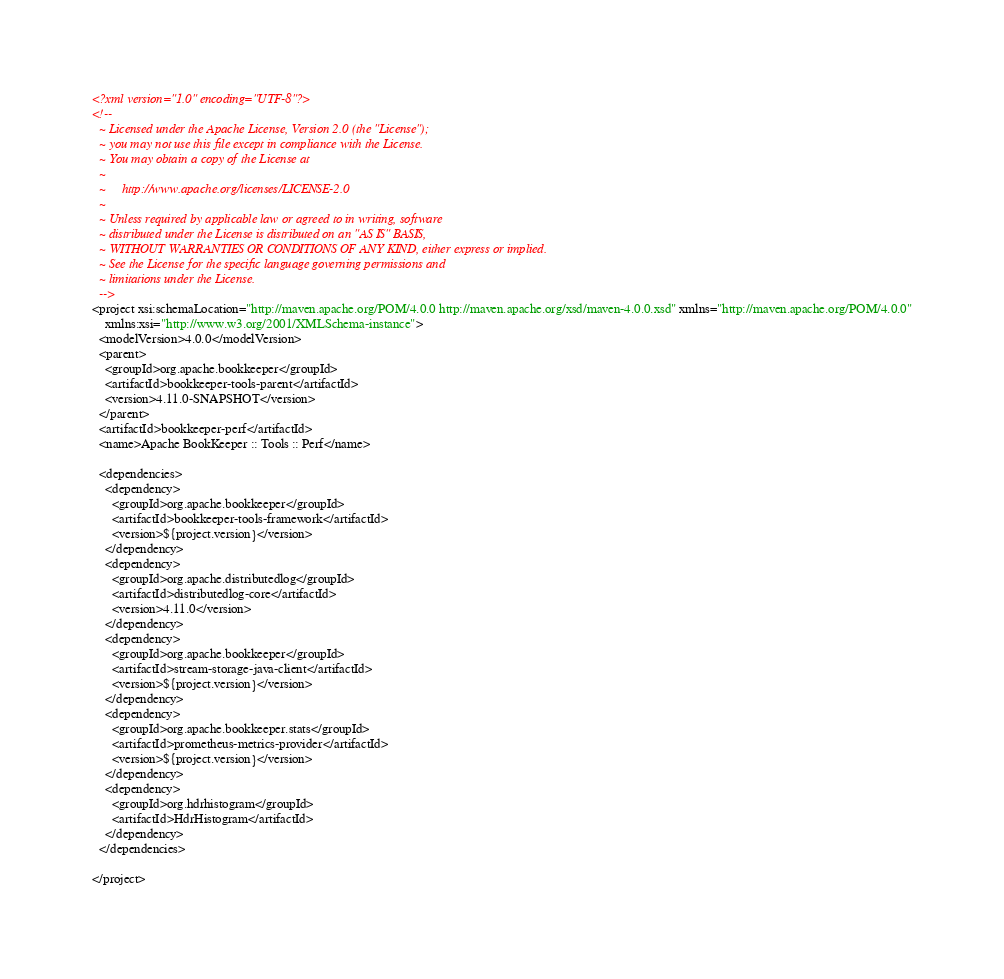Convert code to text. <code><loc_0><loc_0><loc_500><loc_500><_XML_><?xml version="1.0" encoding="UTF-8"?>
<!--
  ~ Licensed under the Apache License, Version 2.0 (the "License");
  ~ you may not use this file except in compliance with the License.
  ~ You may obtain a copy of the License at
  ~
  ~     http://www.apache.org/licenses/LICENSE-2.0
  ~
  ~ Unless required by applicable law or agreed to in writing, software
  ~ distributed under the License is distributed on an "AS IS" BASIS,
  ~ WITHOUT WARRANTIES OR CONDITIONS OF ANY KIND, either express or implied.
  ~ See the License for the specific language governing permissions and
  ~ limitations under the License.
  -->
<project xsi:schemaLocation="http://maven.apache.org/POM/4.0.0 http://maven.apache.org/xsd/maven-4.0.0.xsd" xmlns="http://maven.apache.org/POM/4.0.0"
    xmlns:xsi="http://www.w3.org/2001/XMLSchema-instance">
  <modelVersion>4.0.0</modelVersion>
  <parent>
    <groupId>org.apache.bookkeeper</groupId>
    <artifactId>bookkeeper-tools-parent</artifactId>
    <version>4.11.0-SNAPSHOT</version>
  </parent>
  <artifactId>bookkeeper-perf</artifactId>
  <name>Apache BookKeeper :: Tools :: Perf</name>

  <dependencies>
    <dependency>
      <groupId>org.apache.bookkeeper</groupId>
      <artifactId>bookkeeper-tools-framework</artifactId>
      <version>${project.version}</version>
    </dependency>
    <dependency>
      <groupId>org.apache.distributedlog</groupId>
      <artifactId>distributedlog-core</artifactId>
      <version>4.11.0</version>
    </dependency>
    <dependency>
      <groupId>org.apache.bookkeeper</groupId>
      <artifactId>stream-storage-java-client</artifactId>
      <version>${project.version}</version>
    </dependency>
    <dependency>
      <groupId>org.apache.bookkeeper.stats</groupId>
      <artifactId>prometheus-metrics-provider</artifactId>
      <version>${project.version}</version>
    </dependency>
    <dependency>
      <groupId>org.hdrhistogram</groupId>
      <artifactId>HdrHistogram</artifactId>
    </dependency>
  </dependencies>

</project>
</code> 